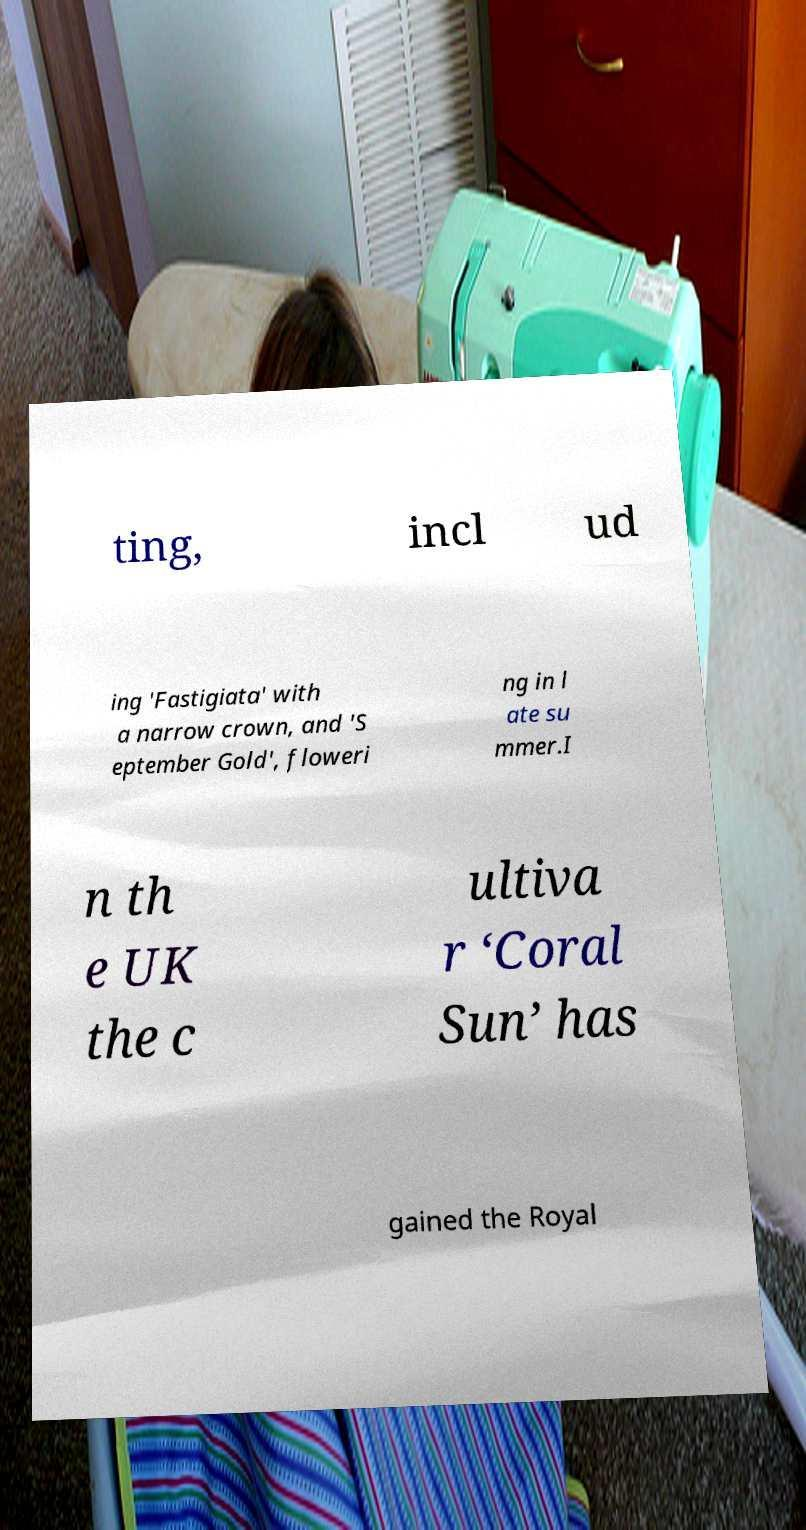Could you assist in decoding the text presented in this image and type it out clearly? ting, incl ud ing 'Fastigiata' with a narrow crown, and 'S eptember Gold', floweri ng in l ate su mmer.I n th e UK the c ultiva r ‘Coral Sun’ has gained the Royal 